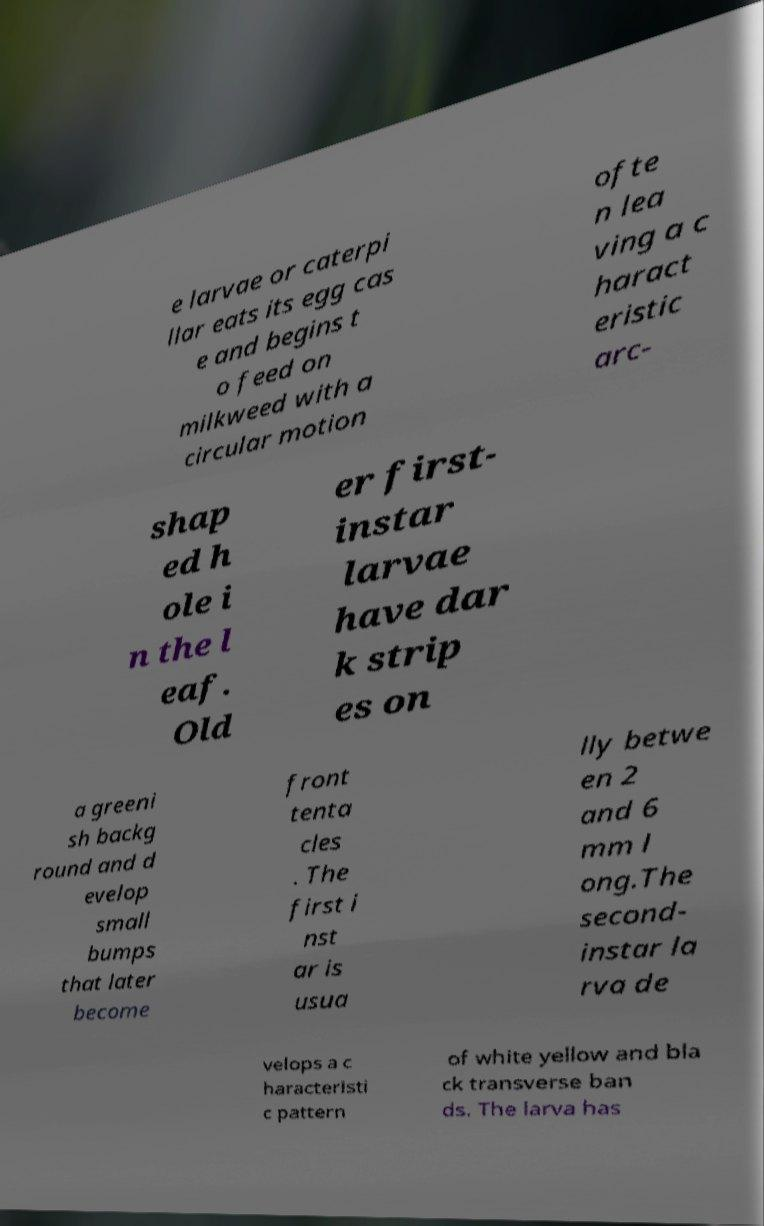Could you assist in decoding the text presented in this image and type it out clearly? e larvae or caterpi llar eats its egg cas e and begins t o feed on milkweed with a circular motion ofte n lea ving a c haract eristic arc- shap ed h ole i n the l eaf. Old er first- instar larvae have dar k strip es on a greeni sh backg round and d evelop small bumps that later become front tenta cles . The first i nst ar is usua lly betwe en 2 and 6 mm l ong.The second- instar la rva de velops a c haracteristi c pattern of white yellow and bla ck transverse ban ds. The larva has 